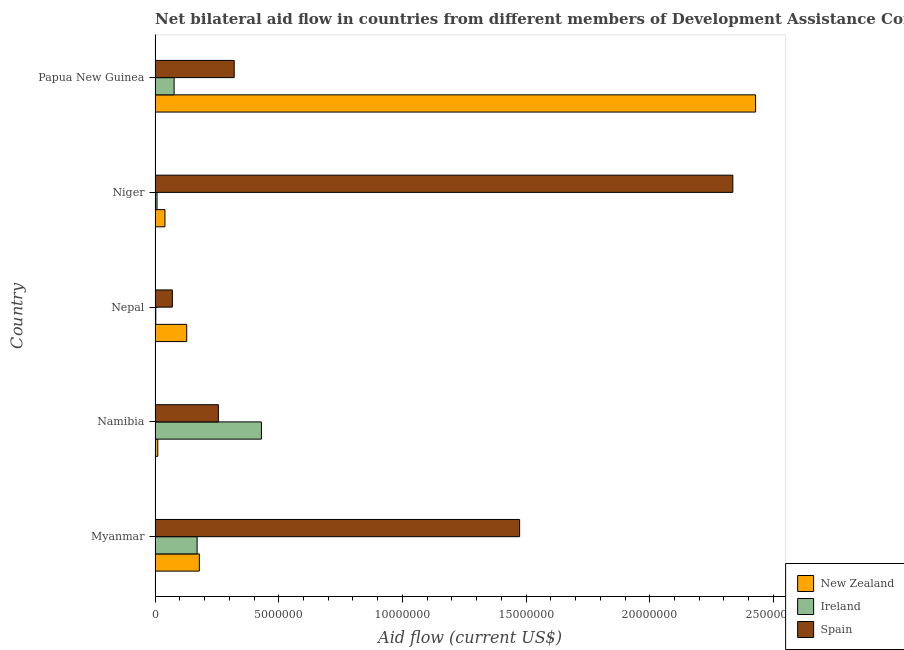How many different coloured bars are there?
Your answer should be very brief. 3. How many groups of bars are there?
Provide a succinct answer. 5. What is the label of the 5th group of bars from the top?
Offer a very short reply. Myanmar. What is the amount of aid provided by new zealand in Niger?
Give a very brief answer. 4.00e+05. Across all countries, what is the maximum amount of aid provided by ireland?
Your response must be concise. 4.30e+06. Across all countries, what is the minimum amount of aid provided by new zealand?
Offer a terse response. 1.10e+05. In which country was the amount of aid provided by ireland maximum?
Ensure brevity in your answer.  Namibia. In which country was the amount of aid provided by spain minimum?
Offer a very short reply. Nepal. What is the total amount of aid provided by spain in the graph?
Keep it short and to the point. 4.46e+07. What is the difference between the amount of aid provided by ireland in Myanmar and that in Nepal?
Keep it short and to the point. 1.67e+06. What is the difference between the amount of aid provided by ireland in Papua New Guinea and the amount of aid provided by new zealand in Myanmar?
Give a very brief answer. -1.02e+06. What is the average amount of aid provided by new zealand per country?
Provide a short and direct response. 5.57e+06. What is the difference between the amount of aid provided by ireland and amount of aid provided by spain in Niger?
Give a very brief answer. -2.33e+07. What is the ratio of the amount of aid provided by ireland in Myanmar to that in Niger?
Keep it short and to the point. 21.25. Is the difference between the amount of aid provided by spain in Myanmar and Nepal greater than the difference between the amount of aid provided by ireland in Myanmar and Nepal?
Give a very brief answer. Yes. What is the difference between the highest and the second highest amount of aid provided by new zealand?
Offer a very short reply. 2.25e+07. What is the difference between the highest and the lowest amount of aid provided by ireland?
Make the answer very short. 4.27e+06. In how many countries, is the amount of aid provided by new zealand greater than the average amount of aid provided by new zealand taken over all countries?
Provide a succinct answer. 1. What does the 3rd bar from the top in Niger represents?
Provide a succinct answer. New Zealand. Is it the case that in every country, the sum of the amount of aid provided by new zealand and amount of aid provided by ireland is greater than the amount of aid provided by spain?
Offer a terse response. No. How many bars are there?
Provide a short and direct response. 15. Are the values on the major ticks of X-axis written in scientific E-notation?
Your answer should be compact. No. Does the graph contain grids?
Ensure brevity in your answer.  No. What is the title of the graph?
Your answer should be very brief. Net bilateral aid flow in countries from different members of Development Assistance Committee. Does "Methane" appear as one of the legend labels in the graph?
Keep it short and to the point. No. What is the label or title of the X-axis?
Offer a very short reply. Aid flow (current US$). What is the Aid flow (current US$) in New Zealand in Myanmar?
Your response must be concise. 1.79e+06. What is the Aid flow (current US$) in Ireland in Myanmar?
Ensure brevity in your answer.  1.70e+06. What is the Aid flow (current US$) in Spain in Myanmar?
Offer a very short reply. 1.47e+07. What is the Aid flow (current US$) in New Zealand in Namibia?
Offer a terse response. 1.10e+05. What is the Aid flow (current US$) of Ireland in Namibia?
Offer a terse response. 4.30e+06. What is the Aid flow (current US$) in Spain in Namibia?
Ensure brevity in your answer.  2.56e+06. What is the Aid flow (current US$) in New Zealand in Nepal?
Keep it short and to the point. 1.28e+06. What is the Aid flow (current US$) in Ireland in Niger?
Provide a succinct answer. 8.00e+04. What is the Aid flow (current US$) in Spain in Niger?
Give a very brief answer. 2.34e+07. What is the Aid flow (current US$) of New Zealand in Papua New Guinea?
Provide a succinct answer. 2.43e+07. What is the Aid flow (current US$) of Ireland in Papua New Guinea?
Make the answer very short. 7.70e+05. What is the Aid flow (current US$) in Spain in Papua New Guinea?
Provide a succinct answer. 3.20e+06. Across all countries, what is the maximum Aid flow (current US$) of New Zealand?
Offer a very short reply. 2.43e+07. Across all countries, what is the maximum Aid flow (current US$) of Ireland?
Make the answer very short. 4.30e+06. Across all countries, what is the maximum Aid flow (current US$) in Spain?
Your answer should be very brief. 2.34e+07. Across all countries, what is the minimum Aid flow (current US$) of Ireland?
Your answer should be compact. 3.00e+04. What is the total Aid flow (current US$) in New Zealand in the graph?
Offer a very short reply. 2.79e+07. What is the total Aid flow (current US$) of Ireland in the graph?
Give a very brief answer. 6.88e+06. What is the total Aid flow (current US$) of Spain in the graph?
Your answer should be very brief. 4.46e+07. What is the difference between the Aid flow (current US$) of New Zealand in Myanmar and that in Namibia?
Make the answer very short. 1.68e+06. What is the difference between the Aid flow (current US$) of Ireland in Myanmar and that in Namibia?
Offer a very short reply. -2.60e+06. What is the difference between the Aid flow (current US$) in Spain in Myanmar and that in Namibia?
Your answer should be compact. 1.22e+07. What is the difference between the Aid flow (current US$) in New Zealand in Myanmar and that in Nepal?
Provide a succinct answer. 5.10e+05. What is the difference between the Aid flow (current US$) of Ireland in Myanmar and that in Nepal?
Your answer should be very brief. 1.67e+06. What is the difference between the Aid flow (current US$) in Spain in Myanmar and that in Nepal?
Make the answer very short. 1.40e+07. What is the difference between the Aid flow (current US$) of New Zealand in Myanmar and that in Niger?
Give a very brief answer. 1.39e+06. What is the difference between the Aid flow (current US$) of Ireland in Myanmar and that in Niger?
Make the answer very short. 1.62e+06. What is the difference between the Aid flow (current US$) of Spain in Myanmar and that in Niger?
Offer a terse response. -8.62e+06. What is the difference between the Aid flow (current US$) of New Zealand in Myanmar and that in Papua New Guinea?
Provide a short and direct response. -2.25e+07. What is the difference between the Aid flow (current US$) in Ireland in Myanmar and that in Papua New Guinea?
Offer a terse response. 9.30e+05. What is the difference between the Aid flow (current US$) of Spain in Myanmar and that in Papua New Guinea?
Your answer should be very brief. 1.15e+07. What is the difference between the Aid flow (current US$) of New Zealand in Namibia and that in Nepal?
Ensure brevity in your answer.  -1.17e+06. What is the difference between the Aid flow (current US$) of Ireland in Namibia and that in Nepal?
Give a very brief answer. 4.27e+06. What is the difference between the Aid flow (current US$) of Spain in Namibia and that in Nepal?
Your response must be concise. 1.86e+06. What is the difference between the Aid flow (current US$) in New Zealand in Namibia and that in Niger?
Your answer should be compact. -2.90e+05. What is the difference between the Aid flow (current US$) of Ireland in Namibia and that in Niger?
Keep it short and to the point. 4.22e+06. What is the difference between the Aid flow (current US$) of Spain in Namibia and that in Niger?
Give a very brief answer. -2.08e+07. What is the difference between the Aid flow (current US$) of New Zealand in Namibia and that in Papua New Guinea?
Provide a short and direct response. -2.42e+07. What is the difference between the Aid flow (current US$) of Ireland in Namibia and that in Papua New Guinea?
Provide a short and direct response. 3.53e+06. What is the difference between the Aid flow (current US$) of Spain in Namibia and that in Papua New Guinea?
Keep it short and to the point. -6.40e+05. What is the difference between the Aid flow (current US$) of New Zealand in Nepal and that in Niger?
Keep it short and to the point. 8.80e+05. What is the difference between the Aid flow (current US$) of Spain in Nepal and that in Niger?
Your answer should be very brief. -2.27e+07. What is the difference between the Aid flow (current US$) of New Zealand in Nepal and that in Papua New Guinea?
Your response must be concise. -2.30e+07. What is the difference between the Aid flow (current US$) in Ireland in Nepal and that in Papua New Guinea?
Ensure brevity in your answer.  -7.40e+05. What is the difference between the Aid flow (current US$) in Spain in Nepal and that in Papua New Guinea?
Your answer should be compact. -2.50e+06. What is the difference between the Aid flow (current US$) of New Zealand in Niger and that in Papua New Guinea?
Offer a very short reply. -2.39e+07. What is the difference between the Aid flow (current US$) in Ireland in Niger and that in Papua New Guinea?
Ensure brevity in your answer.  -6.90e+05. What is the difference between the Aid flow (current US$) in Spain in Niger and that in Papua New Guinea?
Your answer should be very brief. 2.02e+07. What is the difference between the Aid flow (current US$) in New Zealand in Myanmar and the Aid flow (current US$) in Ireland in Namibia?
Offer a very short reply. -2.51e+06. What is the difference between the Aid flow (current US$) in New Zealand in Myanmar and the Aid flow (current US$) in Spain in Namibia?
Provide a succinct answer. -7.70e+05. What is the difference between the Aid flow (current US$) in Ireland in Myanmar and the Aid flow (current US$) in Spain in Namibia?
Offer a very short reply. -8.60e+05. What is the difference between the Aid flow (current US$) of New Zealand in Myanmar and the Aid flow (current US$) of Ireland in Nepal?
Provide a short and direct response. 1.76e+06. What is the difference between the Aid flow (current US$) in New Zealand in Myanmar and the Aid flow (current US$) in Spain in Nepal?
Ensure brevity in your answer.  1.09e+06. What is the difference between the Aid flow (current US$) in New Zealand in Myanmar and the Aid flow (current US$) in Ireland in Niger?
Ensure brevity in your answer.  1.71e+06. What is the difference between the Aid flow (current US$) of New Zealand in Myanmar and the Aid flow (current US$) of Spain in Niger?
Your answer should be very brief. -2.16e+07. What is the difference between the Aid flow (current US$) of Ireland in Myanmar and the Aid flow (current US$) of Spain in Niger?
Your response must be concise. -2.17e+07. What is the difference between the Aid flow (current US$) in New Zealand in Myanmar and the Aid flow (current US$) in Ireland in Papua New Guinea?
Offer a very short reply. 1.02e+06. What is the difference between the Aid flow (current US$) of New Zealand in Myanmar and the Aid flow (current US$) of Spain in Papua New Guinea?
Keep it short and to the point. -1.41e+06. What is the difference between the Aid flow (current US$) of Ireland in Myanmar and the Aid flow (current US$) of Spain in Papua New Guinea?
Make the answer very short. -1.50e+06. What is the difference between the Aid flow (current US$) in New Zealand in Namibia and the Aid flow (current US$) in Spain in Nepal?
Offer a terse response. -5.90e+05. What is the difference between the Aid flow (current US$) of Ireland in Namibia and the Aid flow (current US$) of Spain in Nepal?
Provide a short and direct response. 3.60e+06. What is the difference between the Aid flow (current US$) of New Zealand in Namibia and the Aid flow (current US$) of Spain in Niger?
Give a very brief answer. -2.32e+07. What is the difference between the Aid flow (current US$) in Ireland in Namibia and the Aid flow (current US$) in Spain in Niger?
Provide a succinct answer. -1.91e+07. What is the difference between the Aid flow (current US$) in New Zealand in Namibia and the Aid flow (current US$) in Ireland in Papua New Guinea?
Keep it short and to the point. -6.60e+05. What is the difference between the Aid flow (current US$) in New Zealand in Namibia and the Aid flow (current US$) in Spain in Papua New Guinea?
Your answer should be compact. -3.09e+06. What is the difference between the Aid flow (current US$) in Ireland in Namibia and the Aid flow (current US$) in Spain in Papua New Guinea?
Ensure brevity in your answer.  1.10e+06. What is the difference between the Aid flow (current US$) in New Zealand in Nepal and the Aid flow (current US$) in Ireland in Niger?
Provide a short and direct response. 1.20e+06. What is the difference between the Aid flow (current US$) in New Zealand in Nepal and the Aid flow (current US$) in Spain in Niger?
Keep it short and to the point. -2.21e+07. What is the difference between the Aid flow (current US$) of Ireland in Nepal and the Aid flow (current US$) of Spain in Niger?
Your answer should be compact. -2.33e+07. What is the difference between the Aid flow (current US$) of New Zealand in Nepal and the Aid flow (current US$) of Ireland in Papua New Guinea?
Keep it short and to the point. 5.10e+05. What is the difference between the Aid flow (current US$) in New Zealand in Nepal and the Aid flow (current US$) in Spain in Papua New Guinea?
Make the answer very short. -1.92e+06. What is the difference between the Aid flow (current US$) in Ireland in Nepal and the Aid flow (current US$) in Spain in Papua New Guinea?
Give a very brief answer. -3.17e+06. What is the difference between the Aid flow (current US$) in New Zealand in Niger and the Aid flow (current US$) in Ireland in Papua New Guinea?
Ensure brevity in your answer.  -3.70e+05. What is the difference between the Aid flow (current US$) in New Zealand in Niger and the Aid flow (current US$) in Spain in Papua New Guinea?
Ensure brevity in your answer.  -2.80e+06. What is the difference between the Aid flow (current US$) in Ireland in Niger and the Aid flow (current US$) in Spain in Papua New Guinea?
Provide a succinct answer. -3.12e+06. What is the average Aid flow (current US$) of New Zealand per country?
Ensure brevity in your answer.  5.57e+06. What is the average Aid flow (current US$) in Ireland per country?
Give a very brief answer. 1.38e+06. What is the average Aid flow (current US$) of Spain per country?
Your response must be concise. 8.91e+06. What is the difference between the Aid flow (current US$) in New Zealand and Aid flow (current US$) in Spain in Myanmar?
Your response must be concise. -1.30e+07. What is the difference between the Aid flow (current US$) of Ireland and Aid flow (current US$) of Spain in Myanmar?
Provide a short and direct response. -1.30e+07. What is the difference between the Aid flow (current US$) in New Zealand and Aid flow (current US$) in Ireland in Namibia?
Your answer should be very brief. -4.19e+06. What is the difference between the Aid flow (current US$) of New Zealand and Aid flow (current US$) of Spain in Namibia?
Keep it short and to the point. -2.45e+06. What is the difference between the Aid flow (current US$) in Ireland and Aid flow (current US$) in Spain in Namibia?
Ensure brevity in your answer.  1.74e+06. What is the difference between the Aid flow (current US$) of New Zealand and Aid flow (current US$) of Ireland in Nepal?
Make the answer very short. 1.25e+06. What is the difference between the Aid flow (current US$) in New Zealand and Aid flow (current US$) in Spain in Nepal?
Your response must be concise. 5.80e+05. What is the difference between the Aid flow (current US$) in Ireland and Aid flow (current US$) in Spain in Nepal?
Keep it short and to the point. -6.70e+05. What is the difference between the Aid flow (current US$) in New Zealand and Aid flow (current US$) in Spain in Niger?
Offer a very short reply. -2.30e+07. What is the difference between the Aid flow (current US$) of Ireland and Aid flow (current US$) of Spain in Niger?
Your answer should be very brief. -2.33e+07. What is the difference between the Aid flow (current US$) in New Zealand and Aid flow (current US$) in Ireland in Papua New Guinea?
Provide a short and direct response. 2.35e+07. What is the difference between the Aid flow (current US$) of New Zealand and Aid flow (current US$) of Spain in Papua New Guinea?
Provide a succinct answer. 2.11e+07. What is the difference between the Aid flow (current US$) of Ireland and Aid flow (current US$) of Spain in Papua New Guinea?
Ensure brevity in your answer.  -2.43e+06. What is the ratio of the Aid flow (current US$) of New Zealand in Myanmar to that in Namibia?
Provide a short and direct response. 16.27. What is the ratio of the Aid flow (current US$) in Ireland in Myanmar to that in Namibia?
Offer a very short reply. 0.4. What is the ratio of the Aid flow (current US$) of Spain in Myanmar to that in Namibia?
Your response must be concise. 5.76. What is the ratio of the Aid flow (current US$) in New Zealand in Myanmar to that in Nepal?
Your answer should be compact. 1.4. What is the ratio of the Aid flow (current US$) of Ireland in Myanmar to that in Nepal?
Provide a succinct answer. 56.67. What is the ratio of the Aid flow (current US$) in Spain in Myanmar to that in Nepal?
Provide a succinct answer. 21.06. What is the ratio of the Aid flow (current US$) of New Zealand in Myanmar to that in Niger?
Provide a succinct answer. 4.47. What is the ratio of the Aid flow (current US$) in Ireland in Myanmar to that in Niger?
Provide a succinct answer. 21.25. What is the ratio of the Aid flow (current US$) in Spain in Myanmar to that in Niger?
Your answer should be compact. 0.63. What is the ratio of the Aid flow (current US$) in New Zealand in Myanmar to that in Papua New Guinea?
Ensure brevity in your answer.  0.07. What is the ratio of the Aid flow (current US$) of Ireland in Myanmar to that in Papua New Guinea?
Offer a very short reply. 2.21. What is the ratio of the Aid flow (current US$) in Spain in Myanmar to that in Papua New Guinea?
Your answer should be compact. 4.61. What is the ratio of the Aid flow (current US$) in New Zealand in Namibia to that in Nepal?
Offer a terse response. 0.09. What is the ratio of the Aid flow (current US$) of Ireland in Namibia to that in Nepal?
Your answer should be compact. 143.33. What is the ratio of the Aid flow (current US$) in Spain in Namibia to that in Nepal?
Offer a very short reply. 3.66. What is the ratio of the Aid flow (current US$) of New Zealand in Namibia to that in Niger?
Offer a very short reply. 0.28. What is the ratio of the Aid flow (current US$) in Ireland in Namibia to that in Niger?
Offer a terse response. 53.75. What is the ratio of the Aid flow (current US$) of Spain in Namibia to that in Niger?
Make the answer very short. 0.11. What is the ratio of the Aid flow (current US$) of New Zealand in Namibia to that in Papua New Guinea?
Keep it short and to the point. 0. What is the ratio of the Aid flow (current US$) in Ireland in Namibia to that in Papua New Guinea?
Your response must be concise. 5.58. What is the ratio of the Aid flow (current US$) in New Zealand in Nepal to that in Niger?
Make the answer very short. 3.2. What is the ratio of the Aid flow (current US$) in Ireland in Nepal to that in Niger?
Provide a succinct answer. 0.38. What is the ratio of the Aid flow (current US$) in Spain in Nepal to that in Niger?
Provide a short and direct response. 0.03. What is the ratio of the Aid flow (current US$) of New Zealand in Nepal to that in Papua New Guinea?
Give a very brief answer. 0.05. What is the ratio of the Aid flow (current US$) in Ireland in Nepal to that in Papua New Guinea?
Provide a short and direct response. 0.04. What is the ratio of the Aid flow (current US$) of Spain in Nepal to that in Papua New Guinea?
Offer a very short reply. 0.22. What is the ratio of the Aid flow (current US$) of New Zealand in Niger to that in Papua New Guinea?
Keep it short and to the point. 0.02. What is the ratio of the Aid flow (current US$) of Ireland in Niger to that in Papua New Guinea?
Your answer should be compact. 0.1. What is the difference between the highest and the second highest Aid flow (current US$) of New Zealand?
Offer a very short reply. 2.25e+07. What is the difference between the highest and the second highest Aid flow (current US$) of Ireland?
Give a very brief answer. 2.60e+06. What is the difference between the highest and the second highest Aid flow (current US$) of Spain?
Your answer should be very brief. 8.62e+06. What is the difference between the highest and the lowest Aid flow (current US$) of New Zealand?
Offer a terse response. 2.42e+07. What is the difference between the highest and the lowest Aid flow (current US$) in Ireland?
Your answer should be compact. 4.27e+06. What is the difference between the highest and the lowest Aid flow (current US$) of Spain?
Offer a very short reply. 2.27e+07. 